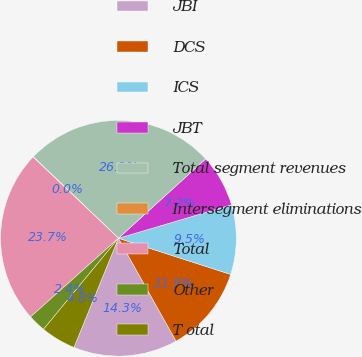Convert chart to OTSL. <chart><loc_0><loc_0><loc_500><loc_500><pie_chart><fcel>JBI<fcel>DCS<fcel>ICS<fcel>JBT<fcel>Total segment revenues<fcel>Intersegment eliminations<fcel>Total<fcel>Other<fcel>T otal<nl><fcel>14.29%<fcel>11.91%<fcel>9.54%<fcel>7.17%<fcel>26.1%<fcel>0.05%<fcel>23.73%<fcel>2.42%<fcel>4.8%<nl></chart> 